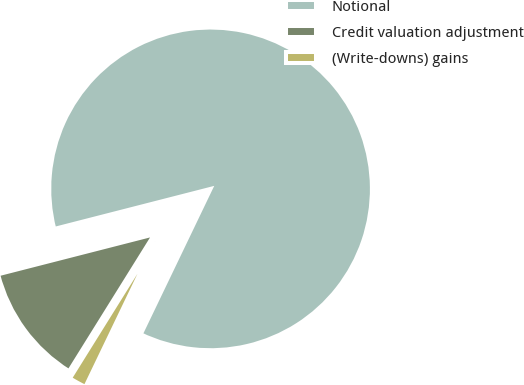Convert chart. <chart><loc_0><loc_0><loc_500><loc_500><pie_chart><fcel>Notional<fcel>Credit valuation adjustment<fcel>(Write-downs) gains<nl><fcel>86.11%<fcel>12.14%<fcel>1.74%<nl></chart> 